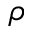<formula> <loc_0><loc_0><loc_500><loc_500>\rho</formula> 